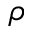<formula> <loc_0><loc_0><loc_500><loc_500>\rho</formula> 